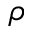<formula> <loc_0><loc_0><loc_500><loc_500>\rho</formula> 